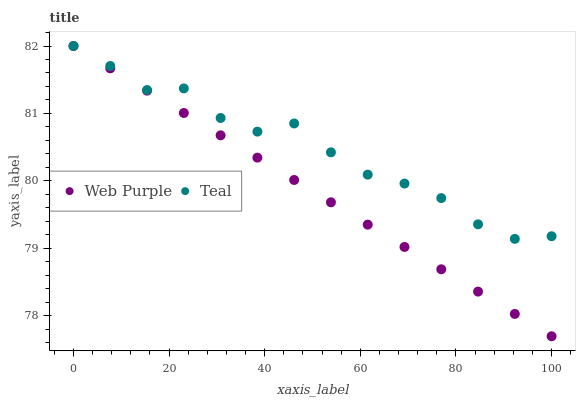Does Web Purple have the minimum area under the curve?
Answer yes or no. Yes. Does Teal have the maximum area under the curve?
Answer yes or no. Yes. Does Teal have the minimum area under the curve?
Answer yes or no. No. Is Web Purple the smoothest?
Answer yes or no. Yes. Is Teal the roughest?
Answer yes or no. Yes. Is Teal the smoothest?
Answer yes or no. No. Does Web Purple have the lowest value?
Answer yes or no. Yes. Does Teal have the lowest value?
Answer yes or no. No. Does Teal have the highest value?
Answer yes or no. Yes. Does Web Purple intersect Teal?
Answer yes or no. Yes. Is Web Purple less than Teal?
Answer yes or no. No. Is Web Purple greater than Teal?
Answer yes or no. No. 